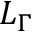Convert formula to latex. <formula><loc_0><loc_0><loc_500><loc_500>L _ { \Gamma }</formula> 